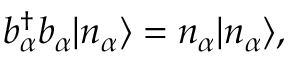<formula> <loc_0><loc_0><loc_500><loc_500>b _ { \alpha } ^ { \dagger } b _ { \alpha } | n _ { \alpha } \rangle = n _ { \alpha } | n _ { \alpha } \rangle ,</formula> 